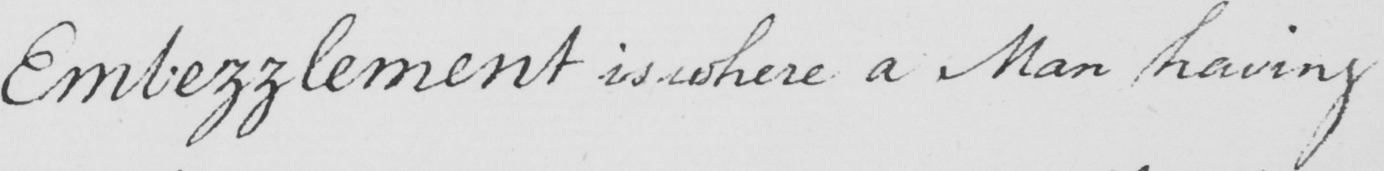What does this handwritten line say? Embezzlement is where a Man having 